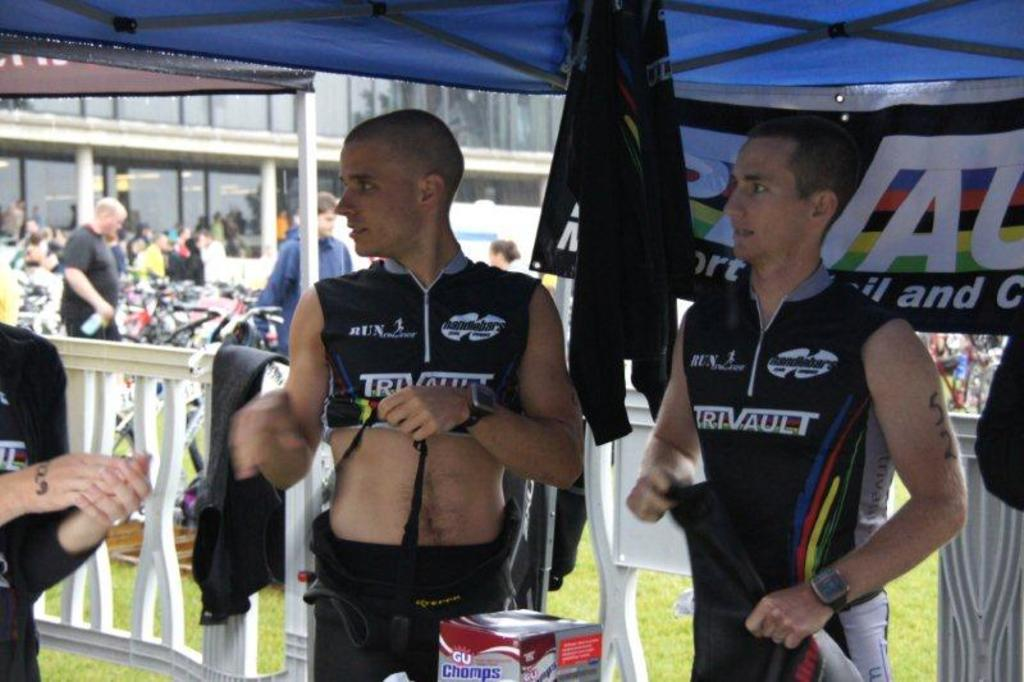<image>
Render a clear and concise summary of the photo. two men in dark trivault jerseys under blue canopy 